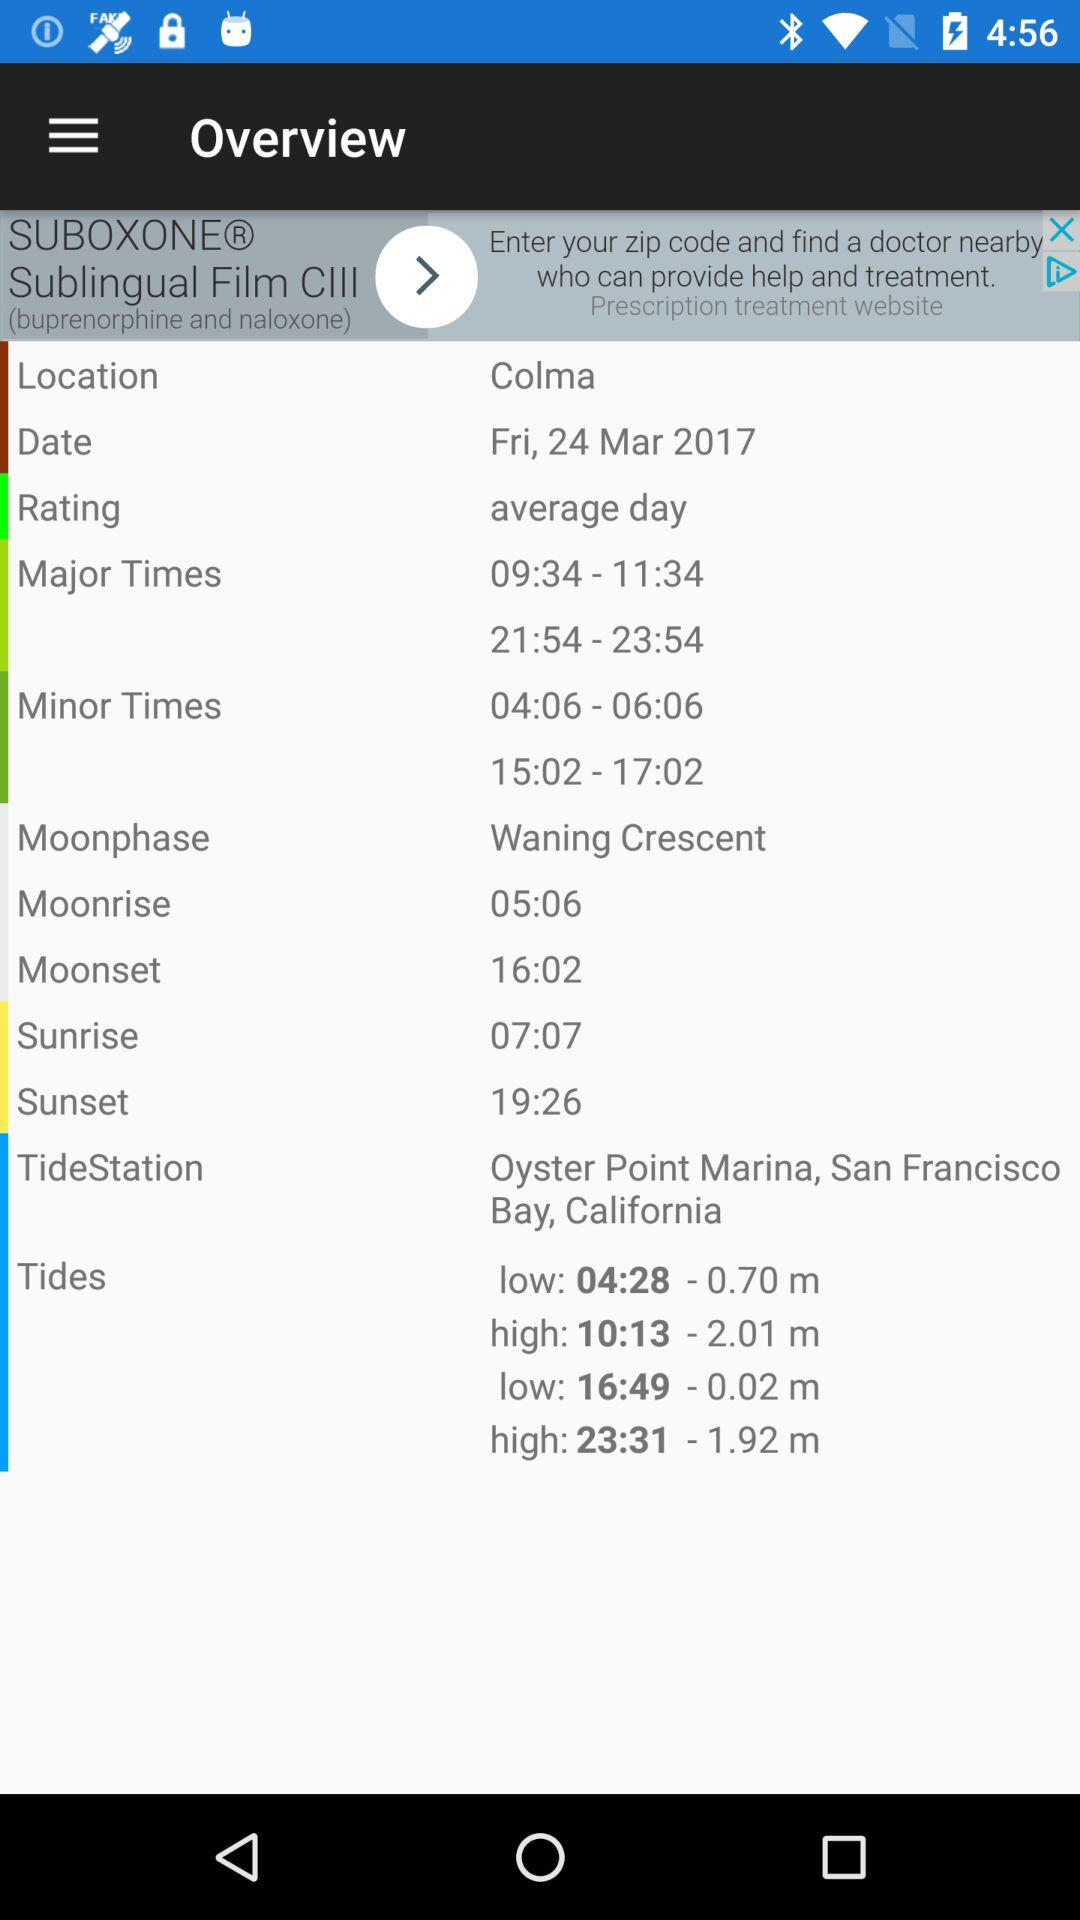What is the sunset time? The sunset time is 19:26. 